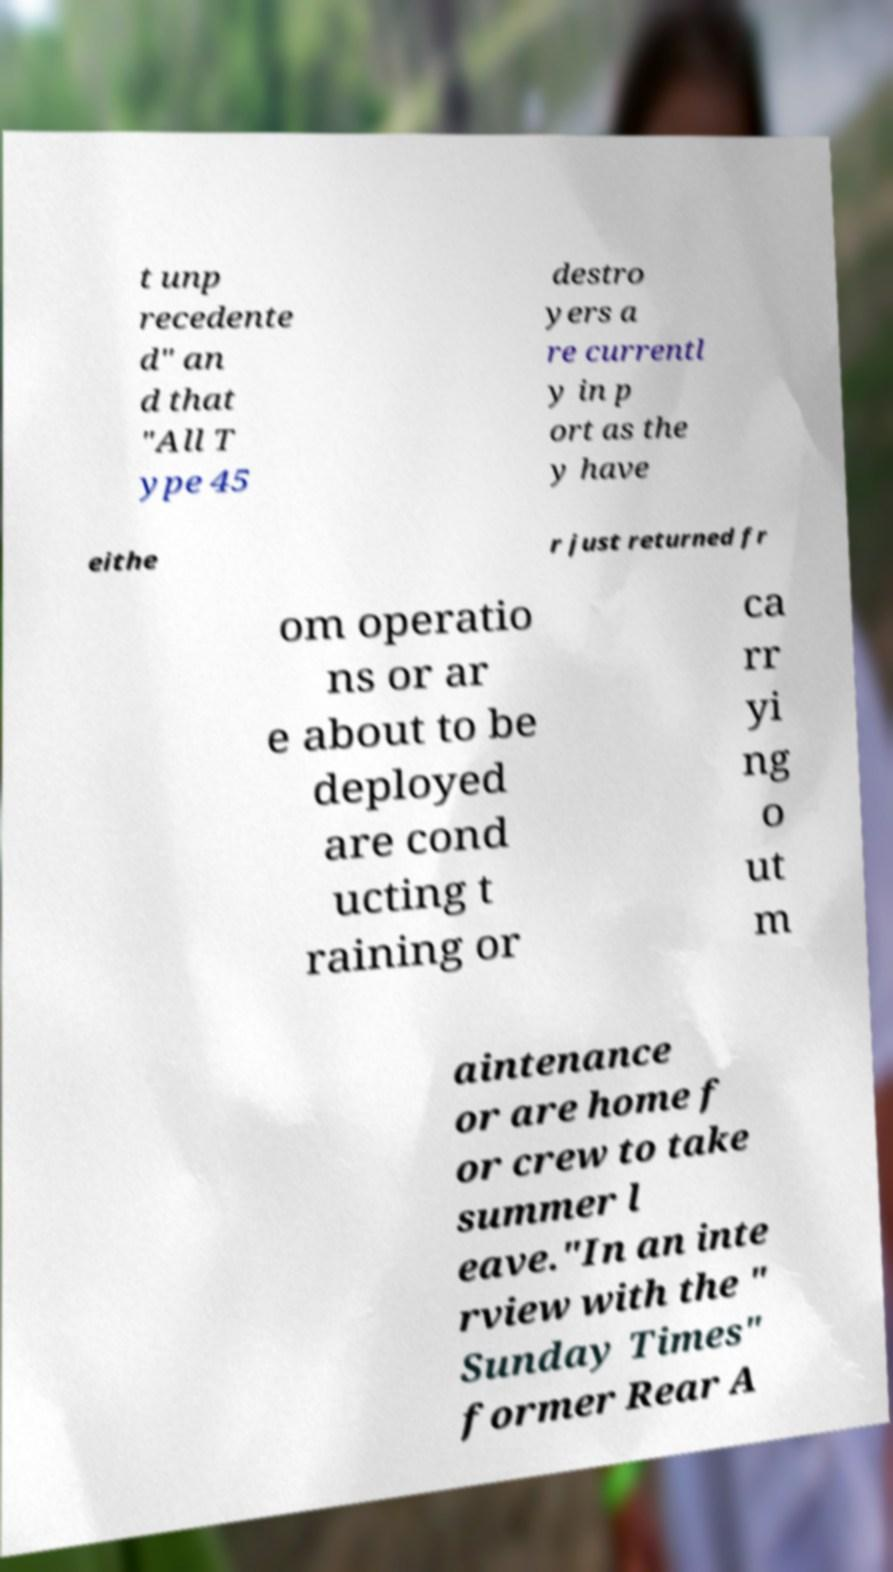I need the written content from this picture converted into text. Can you do that? t unp recedente d" an d that "All T ype 45 destro yers a re currentl y in p ort as the y have eithe r just returned fr om operatio ns or ar e about to be deployed are cond ucting t raining or ca rr yi ng o ut m aintenance or are home f or crew to take summer l eave."In an inte rview with the " Sunday Times" former Rear A 